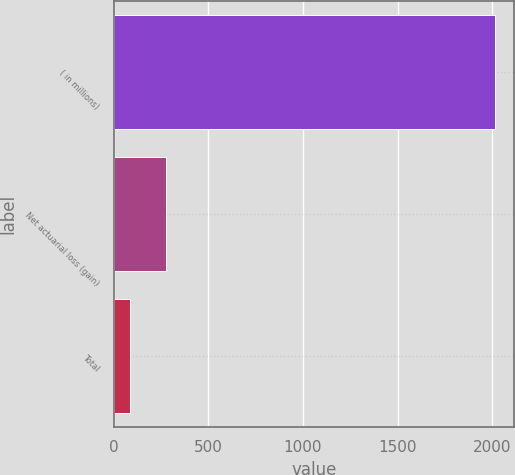Convert chart. <chart><loc_0><loc_0><loc_500><loc_500><bar_chart><fcel>( in millions)<fcel>Net actuarial loss (gain)<fcel>Total<nl><fcel>2016<fcel>276.93<fcel>83.7<nl></chart> 